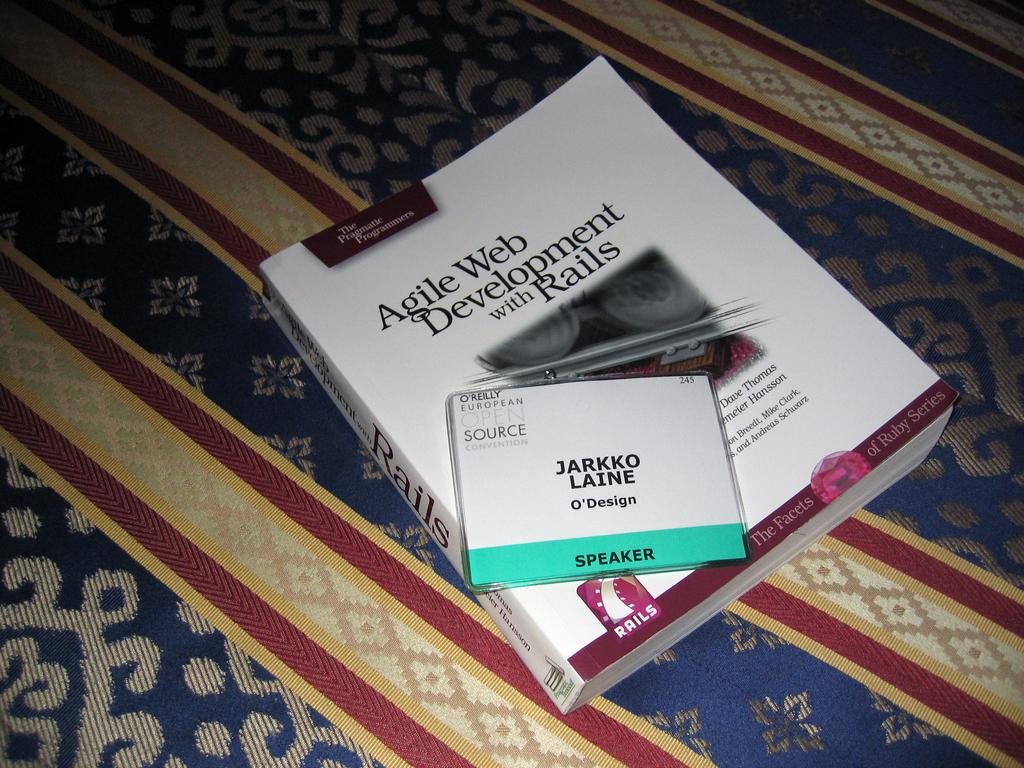Who is the speaker?
Provide a short and direct response. Jarkko laine. What is the name of the book?
Provide a short and direct response. Agile web development with rails. 